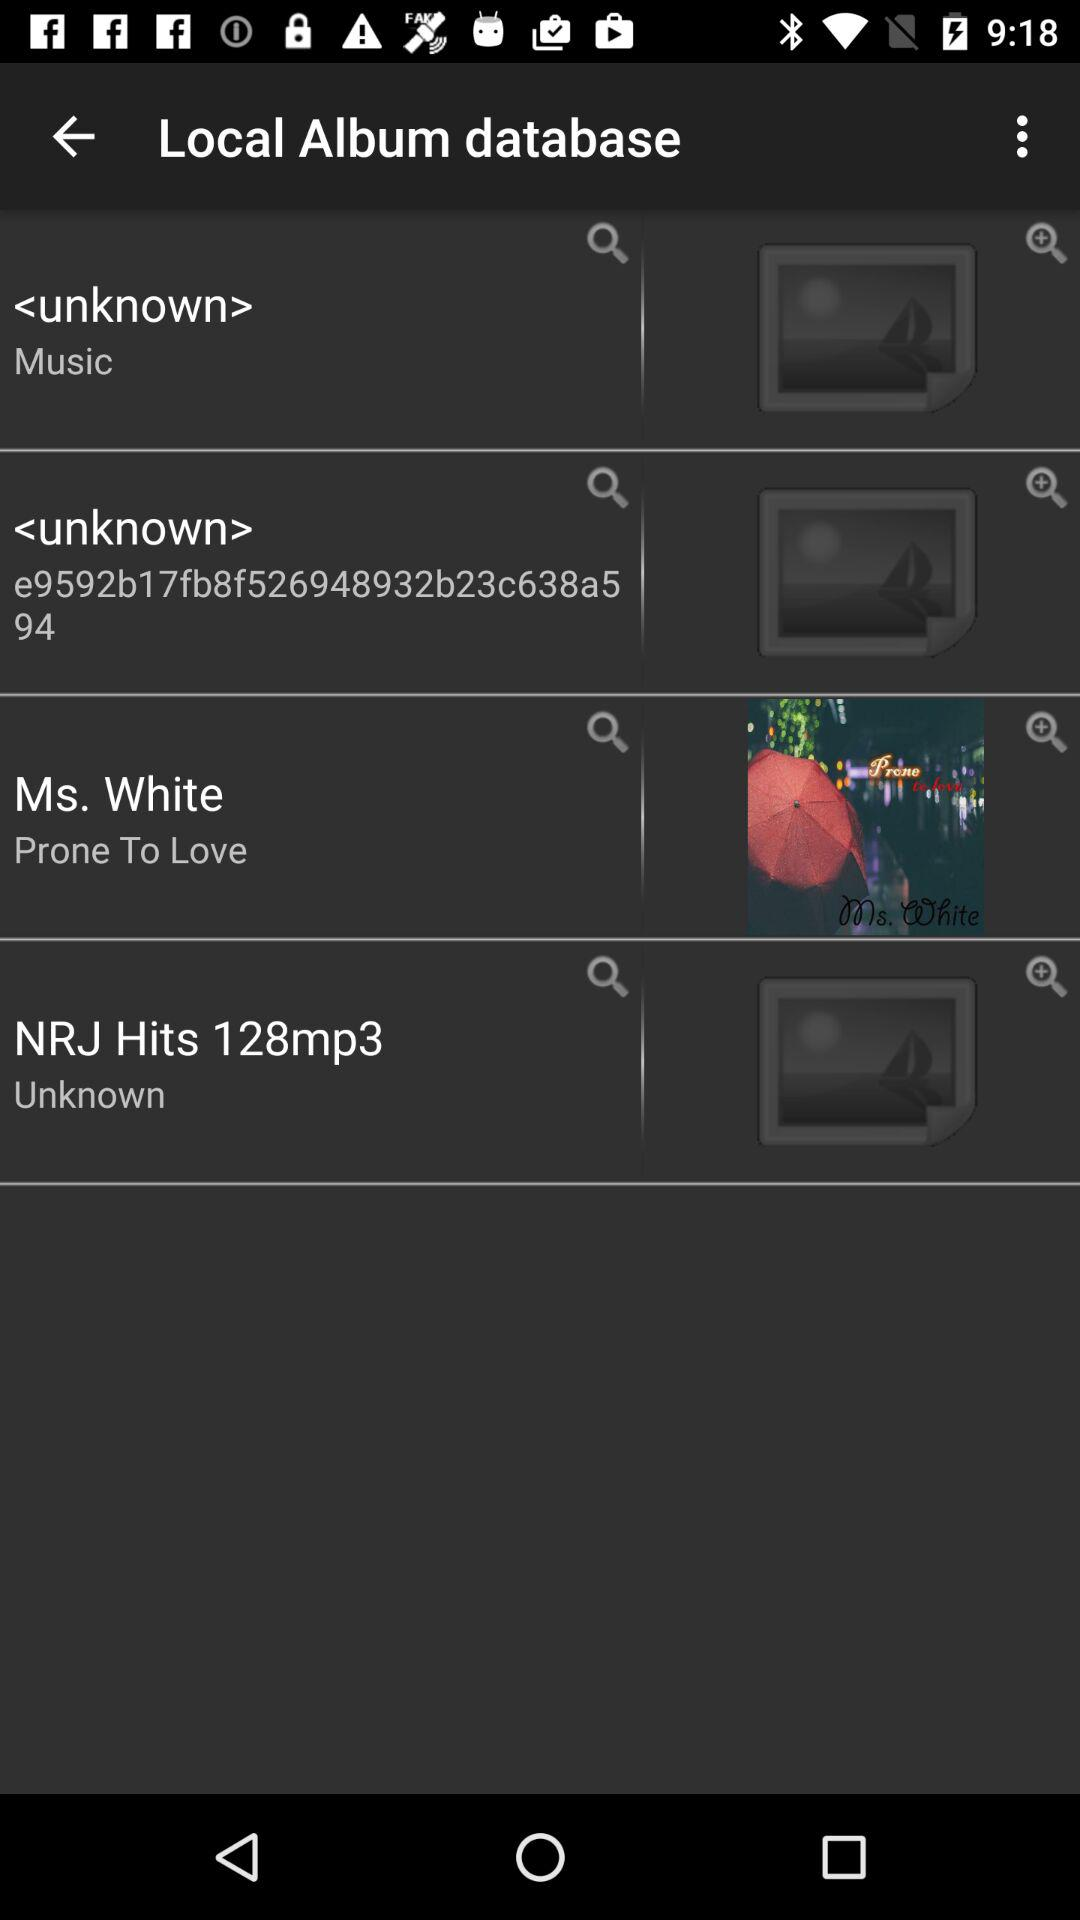Who's the artist of "Prone To Love"? The artist of "Prone To Love" is Ms. White. 